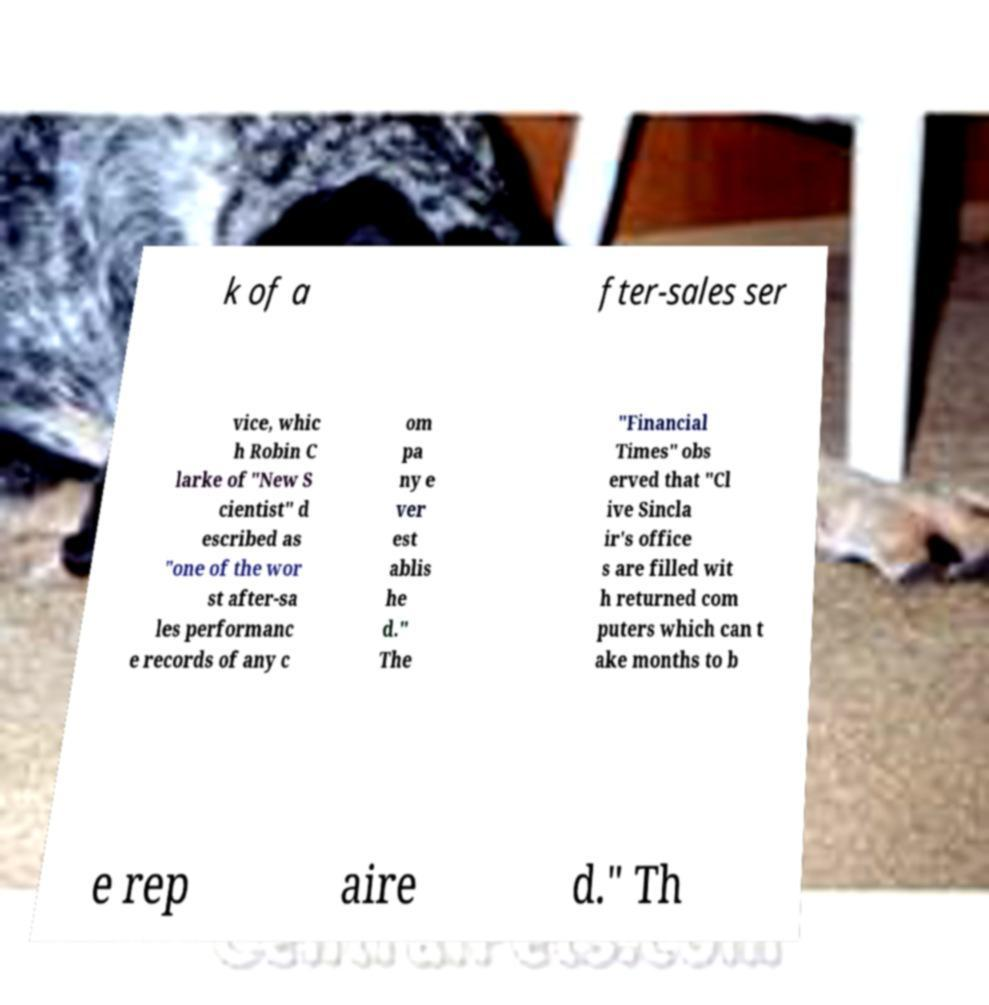Can you accurately transcribe the text from the provided image for me? k of a fter-sales ser vice, whic h Robin C larke of "New S cientist" d escribed as "one of the wor st after-sa les performanc e records of any c om pa ny e ver est ablis he d." The "Financial Times" obs erved that "Cl ive Sincla ir's office s are filled wit h returned com puters which can t ake months to b e rep aire d." Th 